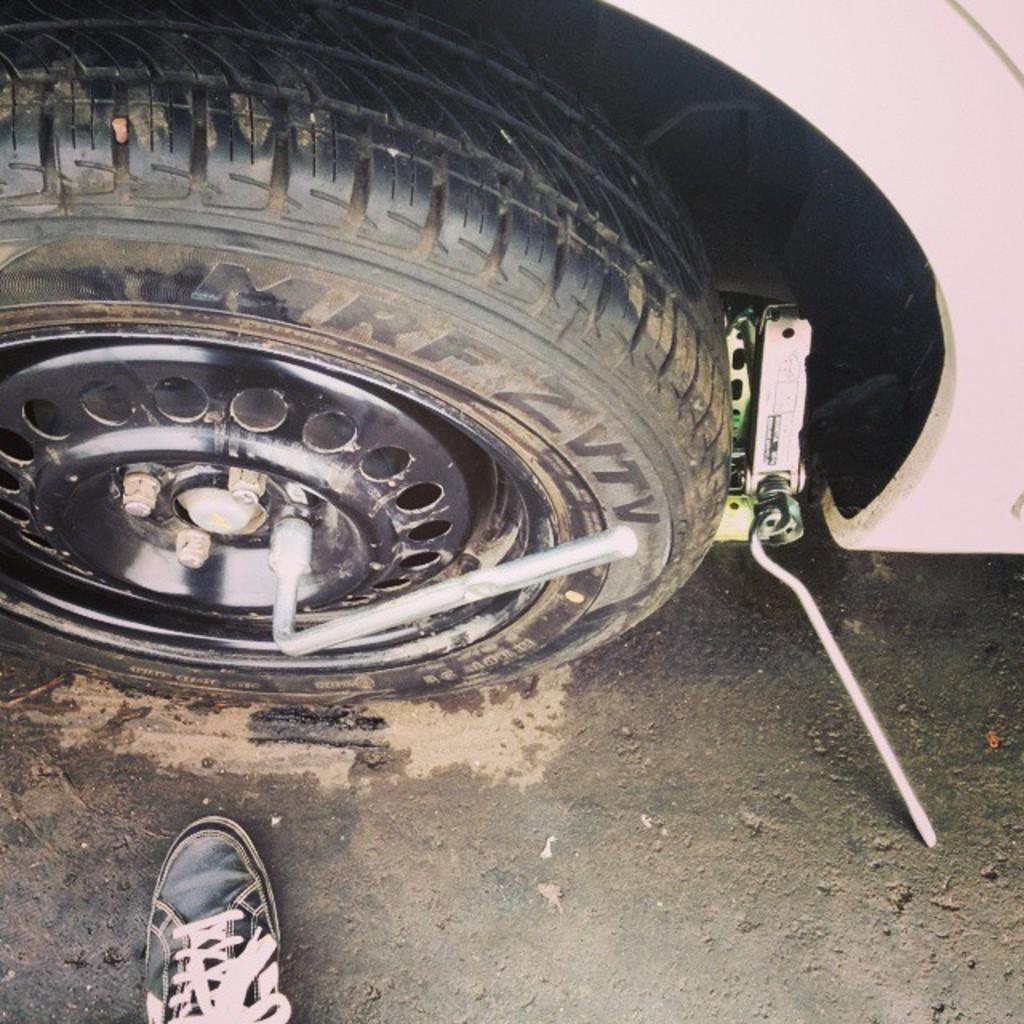Could you give a brief overview of what you see in this image? In the image there is a wheel of a vehicle and in front of the wheel there is a truncated shoe. 